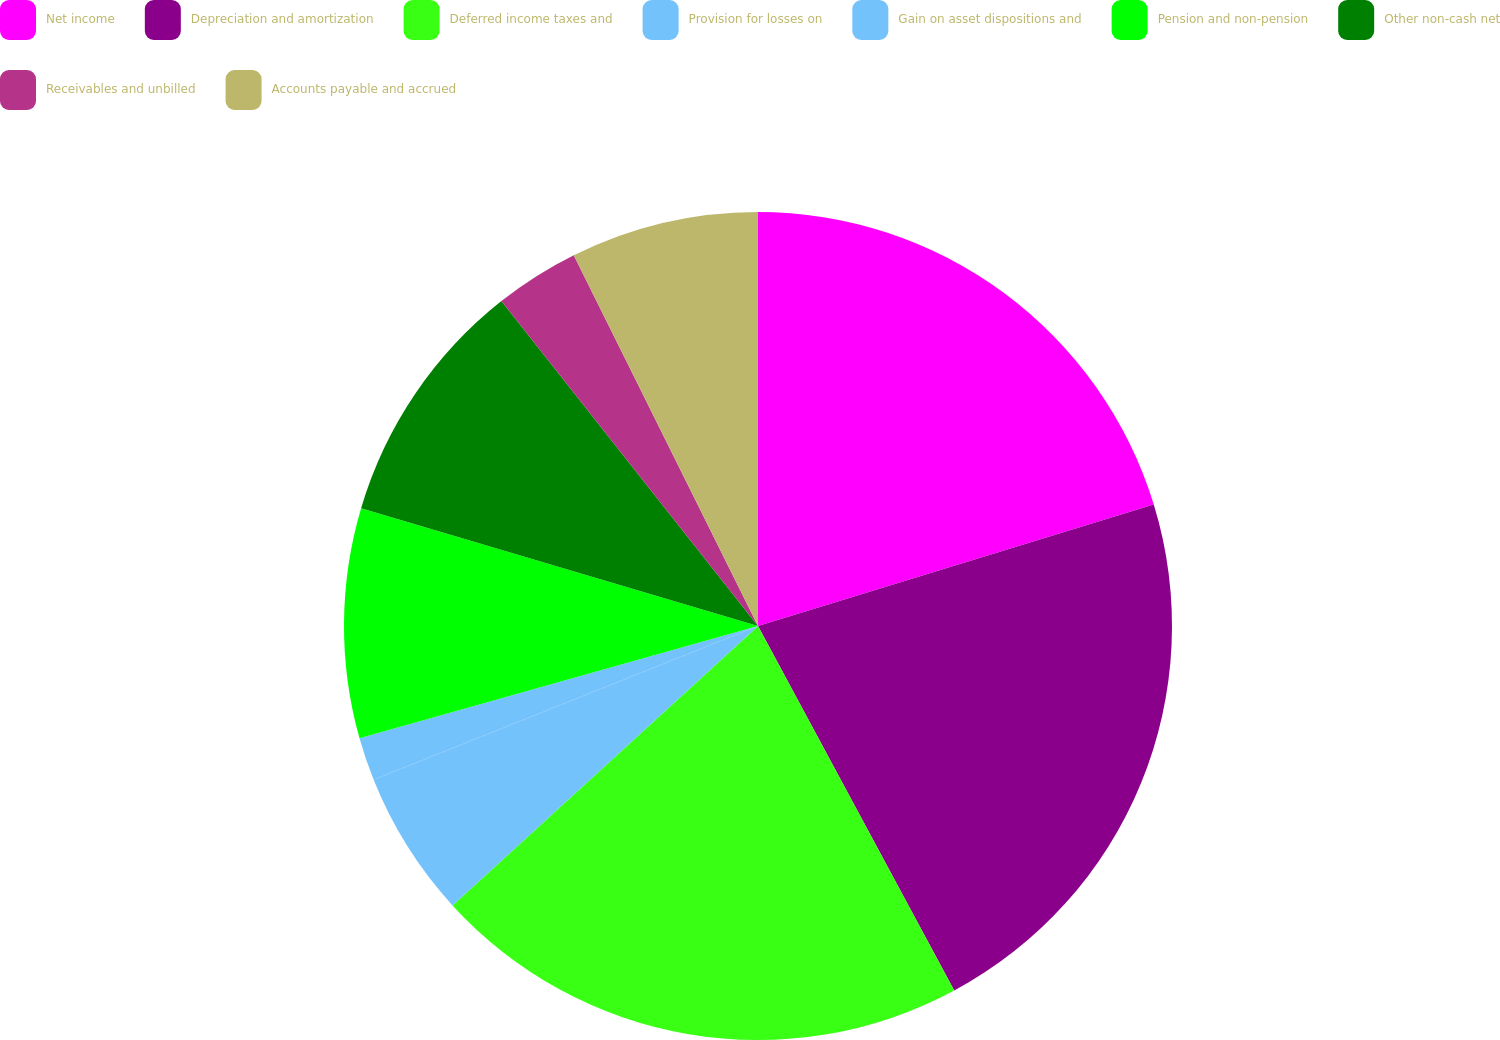Convert chart. <chart><loc_0><loc_0><loc_500><loc_500><pie_chart><fcel>Net income<fcel>Depreciation and amortization<fcel>Deferred income taxes and<fcel>Provision for losses on<fcel>Gain on asset dispositions and<fcel>Pension and non-pension<fcel>Other non-cash net<fcel>Receivables and unbilled<fcel>Accounts payable and accrued<nl><fcel>20.26%<fcel>21.88%<fcel>21.07%<fcel>5.73%<fcel>1.69%<fcel>8.96%<fcel>9.77%<fcel>3.3%<fcel>7.34%<nl></chart> 